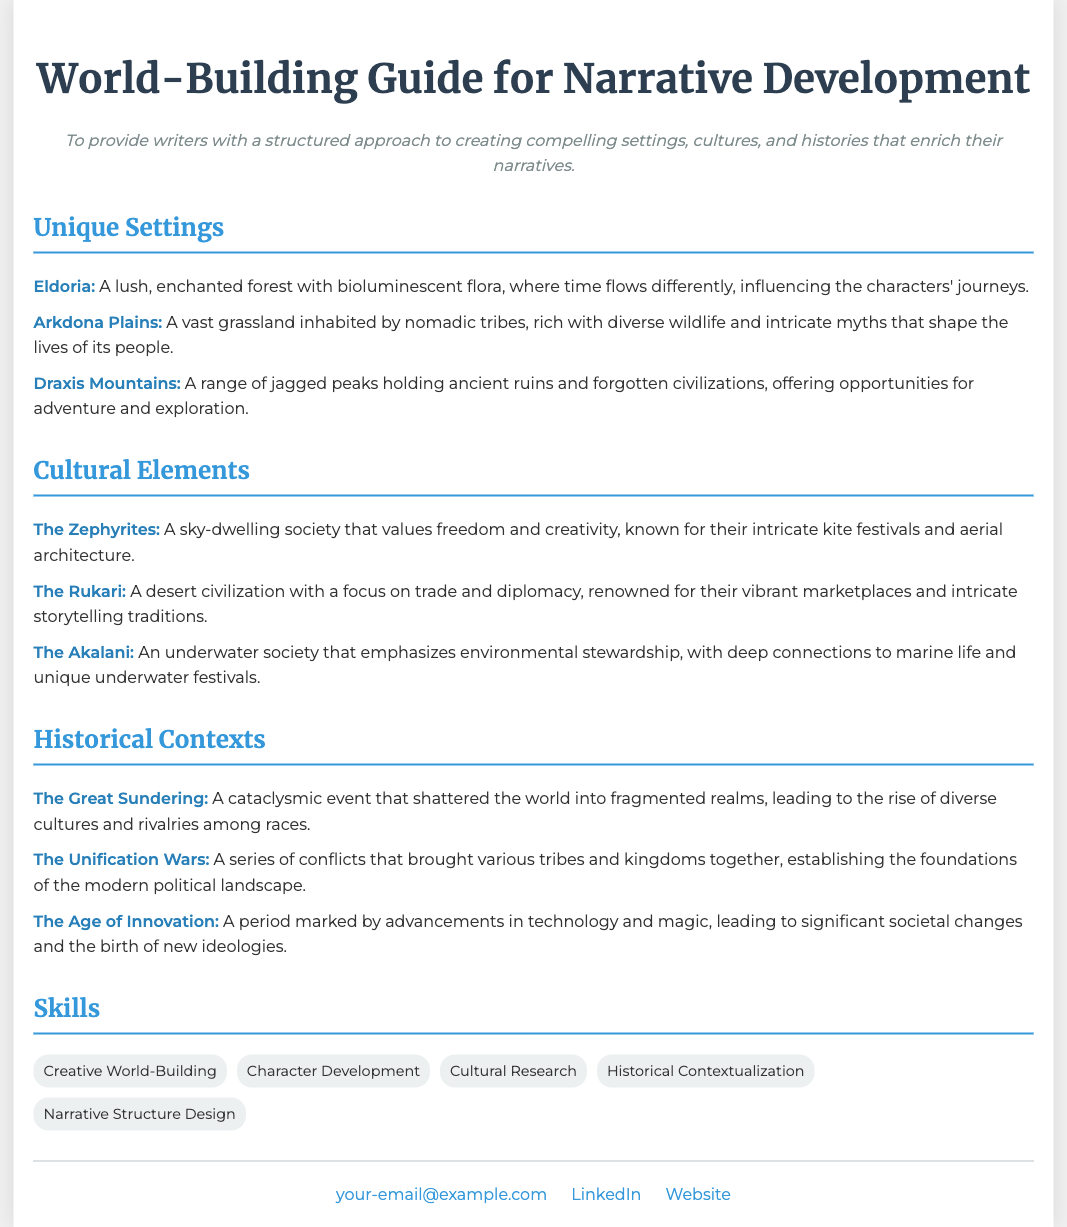What is the title of the document? The title of the document is stated in the header section as the main heading.
Answer: World-Building Guide for Narrative Development What is the objective of the guide? The objective provides insight into the purpose of the document, found directly below the title.
Answer: To provide writers with a structured approach to creating compelling settings, cultures, and histories that enrich their narratives How many unique settings are listed? The document contains a numbered list of unique settings provided in the Unique Settings section.
Answer: Three What is the name of the underwater society mentioned? This information can be found in the Cultural Elements section, referring to one of the cultures.
Answer: The Akalani What major historical event is labeled as a cataclysmic event? This detail is specified in the Historical Contexts section, which provides distinct historical events.
Answer: The Great Sundering Which culture is known for kite festivals? This information is identified in the Cultural Elements section, highlighting a specific society's tradition.
Answer: The Zephyrites How many skills are listed in the Skills section? The count is derived from the number of skills presented within the Skills section of the document.
Answer: Five What is the color of the text for the cultural elements? The color style for cultural elements can be discerned from the formatting in the Cultural Elements section.
Answer: Blue What two objects signify the contact information? The objects are explicitly mentioned in the contact section, indicating their purpose.
Answer: Email and LinkedIn 